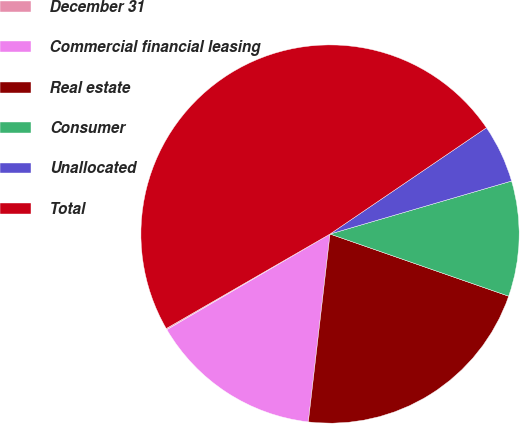Convert chart. <chart><loc_0><loc_0><loc_500><loc_500><pie_chart><fcel>December 31<fcel>Commercial financial leasing<fcel>Real estate<fcel>Consumer<fcel>Unallocated<fcel>Total<nl><fcel>0.11%<fcel>14.73%<fcel>21.5%<fcel>9.85%<fcel>4.98%<fcel>48.83%<nl></chart> 